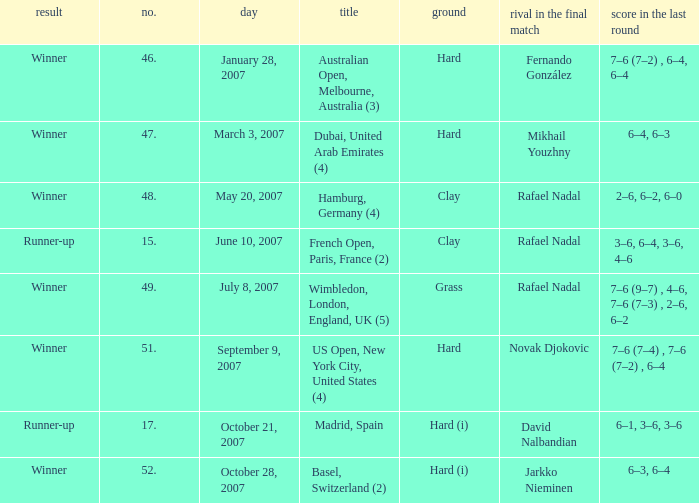Where does the competition take place with a final score of 6–1, 3–6, 3–6? Madrid, Spain. 